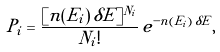Convert formula to latex. <formula><loc_0><loc_0><loc_500><loc_500>P _ { i } = \frac { [ n ( E _ { i } ) \, \delta E ] ^ { N _ { i } } } { N _ { i } ! } \, e ^ { - n ( E _ { i } ) \, \delta E } ,</formula> 